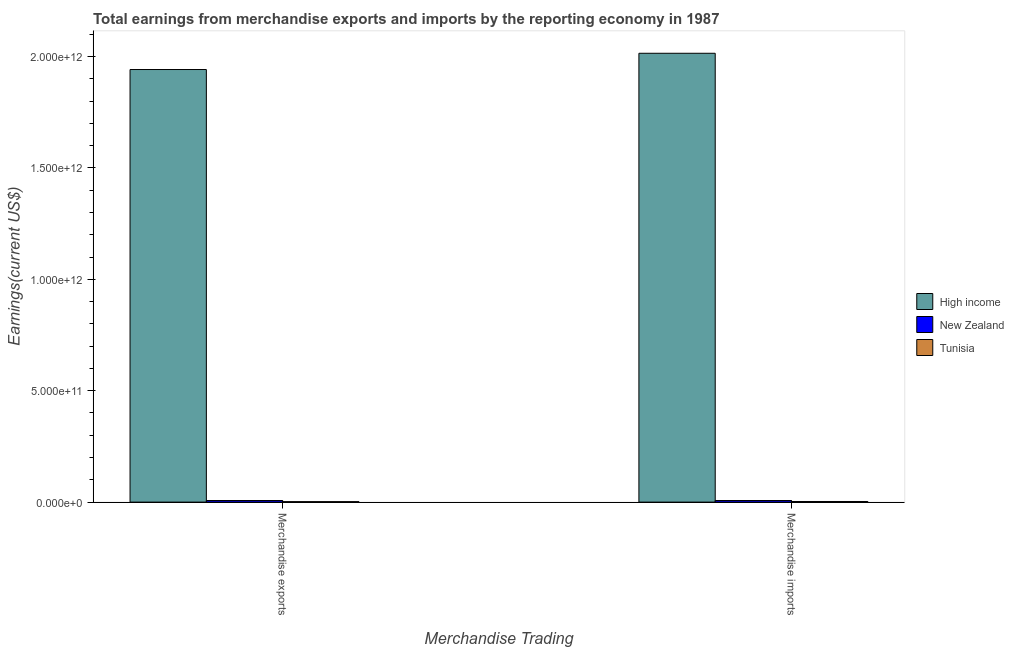What is the earnings from merchandise exports in High income?
Your response must be concise. 1.94e+12. Across all countries, what is the maximum earnings from merchandise exports?
Your response must be concise. 1.94e+12. Across all countries, what is the minimum earnings from merchandise exports?
Offer a very short reply. 2.14e+09. In which country was the earnings from merchandise exports maximum?
Give a very brief answer. High income. In which country was the earnings from merchandise imports minimum?
Provide a succinct answer. Tunisia. What is the total earnings from merchandise imports in the graph?
Your response must be concise. 2.02e+12. What is the difference between the earnings from merchandise exports in High income and that in Tunisia?
Offer a terse response. 1.94e+12. What is the difference between the earnings from merchandise imports in High income and the earnings from merchandise exports in Tunisia?
Ensure brevity in your answer.  2.01e+12. What is the average earnings from merchandise exports per country?
Offer a terse response. 6.50e+11. What is the difference between the earnings from merchandise imports and earnings from merchandise exports in High income?
Make the answer very short. 7.29e+1. In how many countries, is the earnings from merchandise imports greater than 2000000000000 US$?
Your answer should be compact. 1. What is the ratio of the earnings from merchandise imports in New Zealand to that in High income?
Keep it short and to the point. 0. Is the earnings from merchandise exports in New Zealand less than that in Tunisia?
Your answer should be compact. No. What does the 2nd bar from the left in Merchandise exports represents?
Provide a succinct answer. New Zealand. How many countries are there in the graph?
Give a very brief answer. 3. What is the difference between two consecutive major ticks on the Y-axis?
Your answer should be compact. 5.00e+11. Does the graph contain grids?
Your answer should be very brief. No. Where does the legend appear in the graph?
Offer a very short reply. Center right. How are the legend labels stacked?
Give a very brief answer. Vertical. What is the title of the graph?
Provide a succinct answer. Total earnings from merchandise exports and imports by the reporting economy in 1987. Does "Cambodia" appear as one of the legend labels in the graph?
Offer a terse response. No. What is the label or title of the X-axis?
Provide a short and direct response. Merchandise Trading. What is the label or title of the Y-axis?
Make the answer very short. Earnings(current US$). What is the Earnings(current US$) of High income in Merchandise exports?
Keep it short and to the point. 1.94e+12. What is the Earnings(current US$) in New Zealand in Merchandise exports?
Your answer should be compact. 7.24e+09. What is the Earnings(current US$) in Tunisia in Merchandise exports?
Provide a short and direct response. 2.14e+09. What is the Earnings(current US$) of High income in Merchandise imports?
Provide a succinct answer. 2.01e+12. What is the Earnings(current US$) of New Zealand in Merchandise imports?
Offer a very short reply. 7.27e+09. What is the Earnings(current US$) of Tunisia in Merchandise imports?
Your answer should be very brief. 2.84e+09. Across all Merchandise Trading, what is the maximum Earnings(current US$) in High income?
Offer a very short reply. 2.01e+12. Across all Merchandise Trading, what is the maximum Earnings(current US$) in New Zealand?
Your response must be concise. 7.27e+09. Across all Merchandise Trading, what is the maximum Earnings(current US$) of Tunisia?
Offer a terse response. 2.84e+09. Across all Merchandise Trading, what is the minimum Earnings(current US$) of High income?
Offer a very short reply. 1.94e+12. Across all Merchandise Trading, what is the minimum Earnings(current US$) of New Zealand?
Keep it short and to the point. 7.24e+09. Across all Merchandise Trading, what is the minimum Earnings(current US$) in Tunisia?
Provide a short and direct response. 2.14e+09. What is the total Earnings(current US$) of High income in the graph?
Make the answer very short. 3.96e+12. What is the total Earnings(current US$) of New Zealand in the graph?
Your answer should be compact. 1.45e+1. What is the total Earnings(current US$) in Tunisia in the graph?
Offer a terse response. 4.97e+09. What is the difference between the Earnings(current US$) in High income in Merchandise exports and that in Merchandise imports?
Your answer should be compact. -7.29e+1. What is the difference between the Earnings(current US$) in New Zealand in Merchandise exports and that in Merchandise imports?
Your answer should be very brief. -3.73e+07. What is the difference between the Earnings(current US$) of Tunisia in Merchandise exports and that in Merchandise imports?
Your answer should be compact. -7.02e+08. What is the difference between the Earnings(current US$) in High income in Merchandise exports and the Earnings(current US$) in New Zealand in Merchandise imports?
Your answer should be compact. 1.93e+12. What is the difference between the Earnings(current US$) of High income in Merchandise exports and the Earnings(current US$) of Tunisia in Merchandise imports?
Give a very brief answer. 1.94e+12. What is the difference between the Earnings(current US$) of New Zealand in Merchandise exports and the Earnings(current US$) of Tunisia in Merchandise imports?
Give a very brief answer. 4.40e+09. What is the average Earnings(current US$) of High income per Merchandise Trading?
Offer a very short reply. 1.98e+12. What is the average Earnings(current US$) of New Zealand per Merchandise Trading?
Your answer should be compact. 7.25e+09. What is the average Earnings(current US$) of Tunisia per Merchandise Trading?
Give a very brief answer. 2.49e+09. What is the difference between the Earnings(current US$) in High income and Earnings(current US$) in New Zealand in Merchandise exports?
Offer a very short reply. 1.93e+12. What is the difference between the Earnings(current US$) in High income and Earnings(current US$) in Tunisia in Merchandise exports?
Provide a short and direct response. 1.94e+12. What is the difference between the Earnings(current US$) in New Zealand and Earnings(current US$) in Tunisia in Merchandise exports?
Give a very brief answer. 5.10e+09. What is the difference between the Earnings(current US$) in High income and Earnings(current US$) in New Zealand in Merchandise imports?
Your answer should be compact. 2.01e+12. What is the difference between the Earnings(current US$) of High income and Earnings(current US$) of Tunisia in Merchandise imports?
Keep it short and to the point. 2.01e+12. What is the difference between the Earnings(current US$) of New Zealand and Earnings(current US$) of Tunisia in Merchandise imports?
Provide a succinct answer. 4.44e+09. What is the ratio of the Earnings(current US$) in High income in Merchandise exports to that in Merchandise imports?
Ensure brevity in your answer.  0.96. What is the ratio of the Earnings(current US$) of Tunisia in Merchandise exports to that in Merchandise imports?
Provide a short and direct response. 0.75. What is the difference between the highest and the second highest Earnings(current US$) in High income?
Give a very brief answer. 7.29e+1. What is the difference between the highest and the second highest Earnings(current US$) of New Zealand?
Make the answer very short. 3.73e+07. What is the difference between the highest and the second highest Earnings(current US$) in Tunisia?
Provide a short and direct response. 7.02e+08. What is the difference between the highest and the lowest Earnings(current US$) of High income?
Give a very brief answer. 7.29e+1. What is the difference between the highest and the lowest Earnings(current US$) of New Zealand?
Give a very brief answer. 3.73e+07. What is the difference between the highest and the lowest Earnings(current US$) of Tunisia?
Keep it short and to the point. 7.02e+08. 